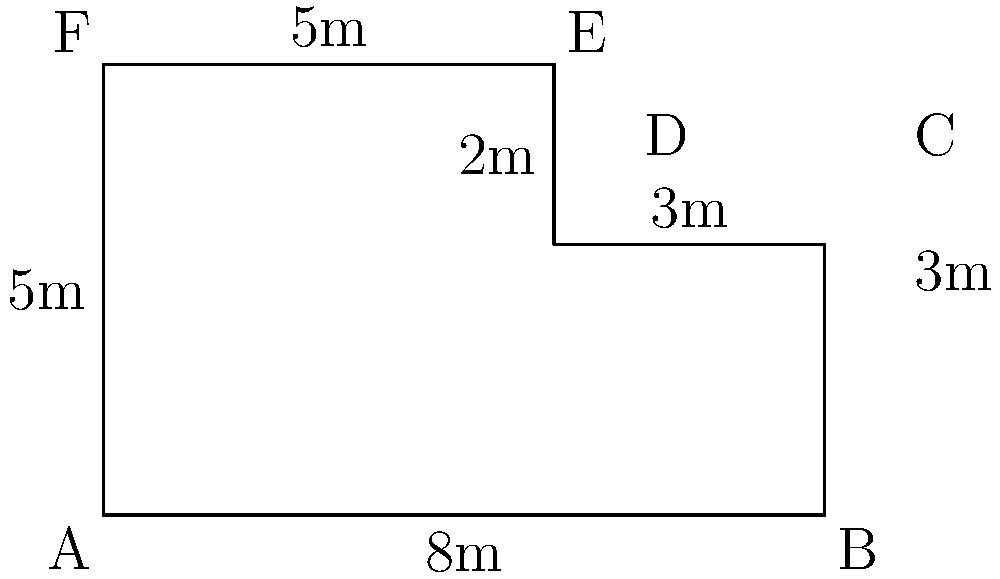As a parent volunteering to help with a school playground project, you're tasked with calculating the perimeter of an irregularly shaped fenced area. The playground's shape is shown in the diagram above. What is the total length of fencing needed to enclose this playground? To calculate the perimeter of the irregular shape, we need to add up the lengths of all sides:

1. Bottom side (AB): 8m
2. Right side (BC): 3m
3. Upper right side (CD): 3m
4. Small right side (DE): 2m
5. Top side (EF): 5m
6. Left side (FA): 5m

Adding all these lengths:

$$\text{Perimeter} = 8m + 3m + 3m + 2m + 5m + 5m = 26m$$

Therefore, the total length of fencing needed to enclose this playground is 26 meters.
Answer: 26 meters 